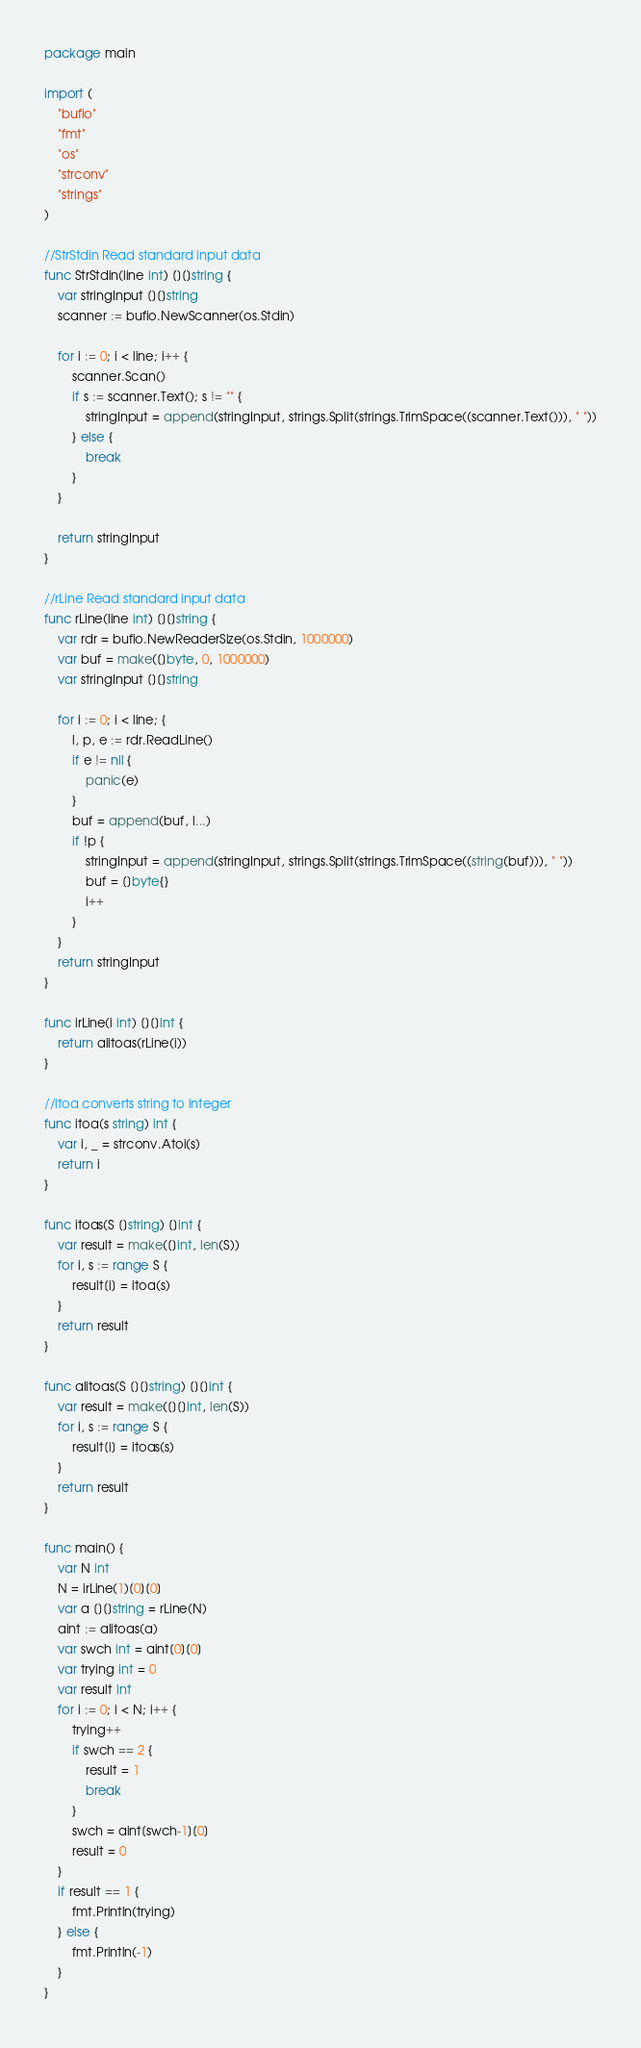<code> <loc_0><loc_0><loc_500><loc_500><_Go_>package main

import (
	"bufio"
	"fmt"
	"os"
	"strconv"
	"strings"
)

//StrStdin Read standard input data
func StrStdin(line int) [][]string {
	var stringInput [][]string
	scanner := bufio.NewScanner(os.Stdin)

	for i := 0; i < line; i++ {
		scanner.Scan()
		if s := scanner.Text(); s != "" {
			stringInput = append(stringInput, strings.Split(strings.TrimSpace((scanner.Text())), " "))
		} else {
			break
		}
	}

	return stringInput
}

//rLine Read standard input data
func rLine(line int) [][]string {
	var rdr = bufio.NewReaderSize(os.Stdin, 1000000)
	var buf = make([]byte, 0, 1000000)
	var stringInput [][]string

	for i := 0; i < line; {
		l, p, e := rdr.ReadLine()
		if e != nil {
			panic(e)
		}
		buf = append(buf, l...)
		if !p {
			stringInput = append(stringInput, strings.Split(strings.TrimSpace((string(buf))), " "))
			buf = []byte{}
			i++
		}
	}
	return stringInput
}

func irLine(i int) [][]int {
	return alitoas(rLine(i))
}

//itoa converts string to integer
func itoa(s string) int {
	var i, _ = strconv.Atoi(s)
	return i
}

func itoas(S []string) []int {
	var result = make([]int, len(S))
	for i, s := range S {
		result[i] = itoa(s)
	}
	return result
}

func alitoas(S [][]string) [][]int {
	var result = make([][]int, len(S))
	for i, s := range S {
		result[i] = itoas(s)
	}
	return result
}

func main() {
	var N int
	N = irLine(1)[0][0]
	var a [][]string = rLine(N)
	aint := alitoas(a)
	var swch int = aint[0][0]
	var trying int = 0
	var result int
	for i := 0; i < N; i++ {
		trying++
		if swch == 2 {
			result = 1
			break
		}
		swch = aint[swch-1][0]
		result = 0
	}
	if result == 1 {
		fmt.Println(trying)
	} else {
		fmt.Println(-1)
	}
}
</code> 